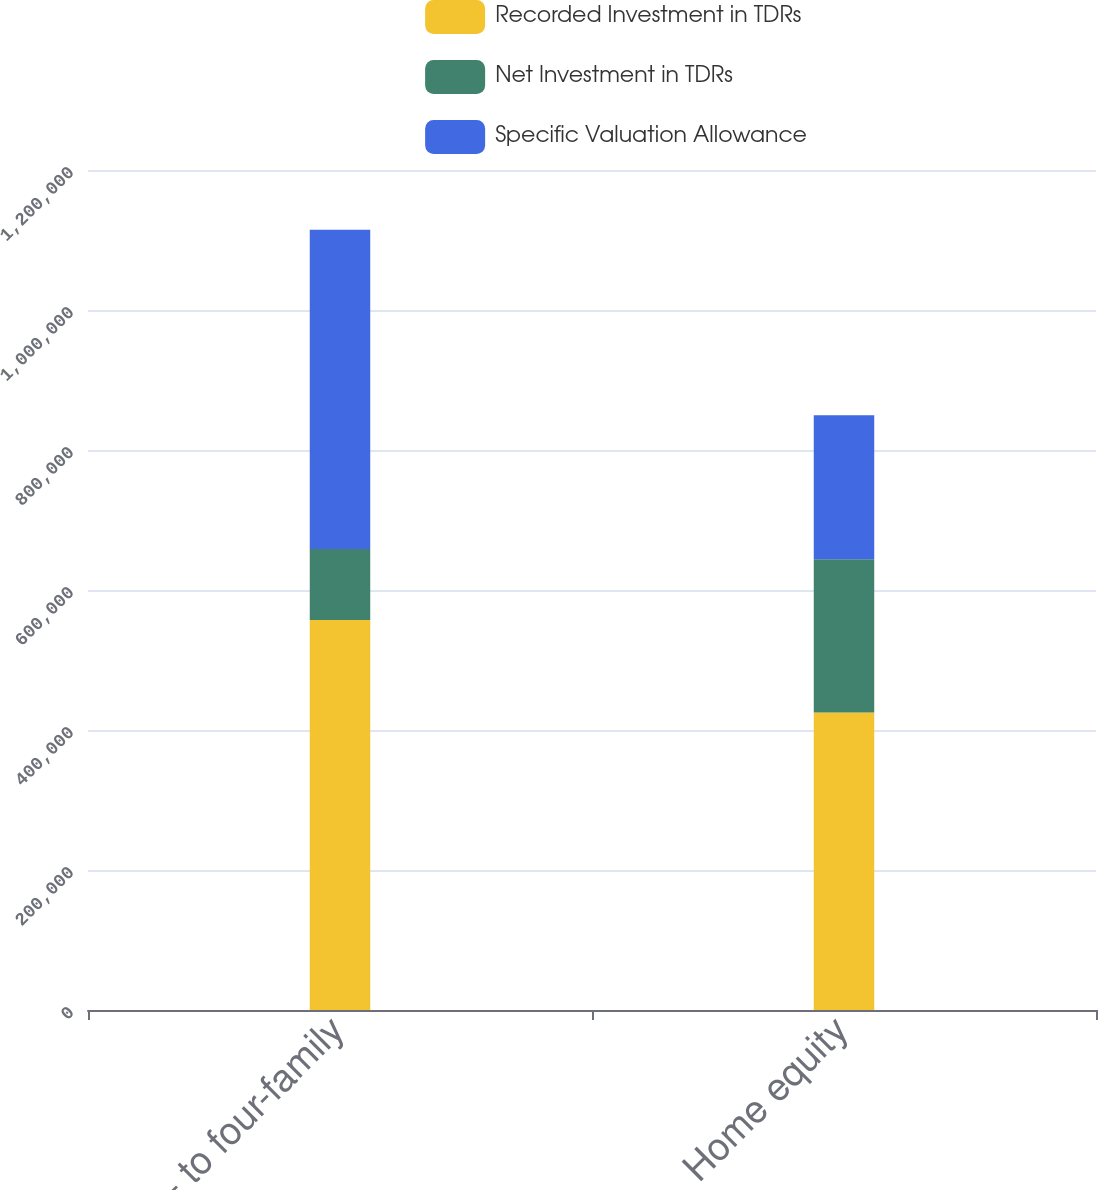Convert chart. <chart><loc_0><loc_0><loc_500><loc_500><stacked_bar_chart><ecel><fcel>One- to four-family<fcel>Home equity<nl><fcel>Recorded Investment in TDRs<fcel>557297<fcel>424834<nl><fcel>Net Investment in TDRs<fcel>101188<fcel>218955<nl><fcel>Specific Valuation Allowance<fcel>456109<fcel>205879<nl></chart> 